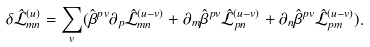Convert formula to latex. <formula><loc_0><loc_0><loc_500><loc_500>\delta { \hat { \mathcal { L } } } _ { m n } ^ { ( u ) } = \sum _ { v } ( { \hat { \beta } } ^ { p v } \partial _ { p } { \hat { \mathcal { L } } } _ { m n } ^ { ( u - v ) } + \partial _ { m } { \hat { \beta } } ^ { p v } { \hat { \mathcal { L } } } _ { p n } ^ { ( u - v ) } + \partial _ { n } { \hat { \beta } } ^ { p v } { \hat { \mathcal { L } } } _ { p m } ^ { ( u - v ) } ) .</formula> 